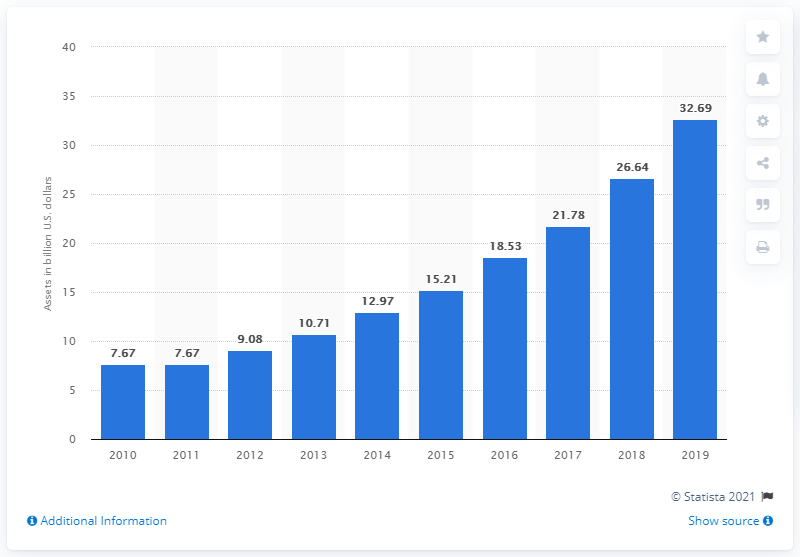Highlight a few significant elements in this photo. The total assets of Sallie Mae in 2019 were 32.69. 